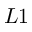<formula> <loc_0><loc_0><loc_500><loc_500>L 1</formula> 